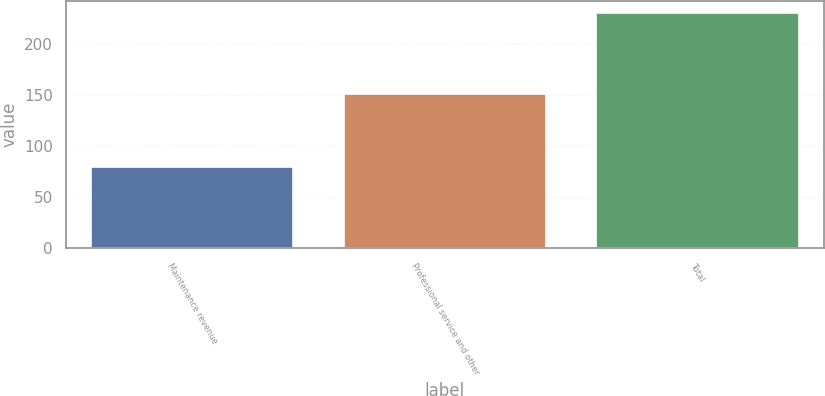Convert chart to OTSL. <chart><loc_0><loc_0><loc_500><loc_500><bar_chart><fcel>Maintenance revenue<fcel>Professional service and other<fcel>Total<nl><fcel>79.2<fcel>151.5<fcel>230.7<nl></chart> 